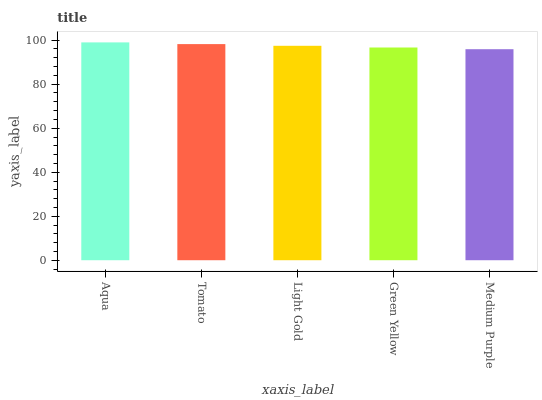Is Tomato the minimum?
Answer yes or no. No. Is Tomato the maximum?
Answer yes or no. No. Is Aqua greater than Tomato?
Answer yes or no. Yes. Is Tomato less than Aqua?
Answer yes or no. Yes. Is Tomato greater than Aqua?
Answer yes or no. No. Is Aqua less than Tomato?
Answer yes or no. No. Is Light Gold the high median?
Answer yes or no. Yes. Is Light Gold the low median?
Answer yes or no. Yes. Is Medium Purple the high median?
Answer yes or no. No. Is Medium Purple the low median?
Answer yes or no. No. 